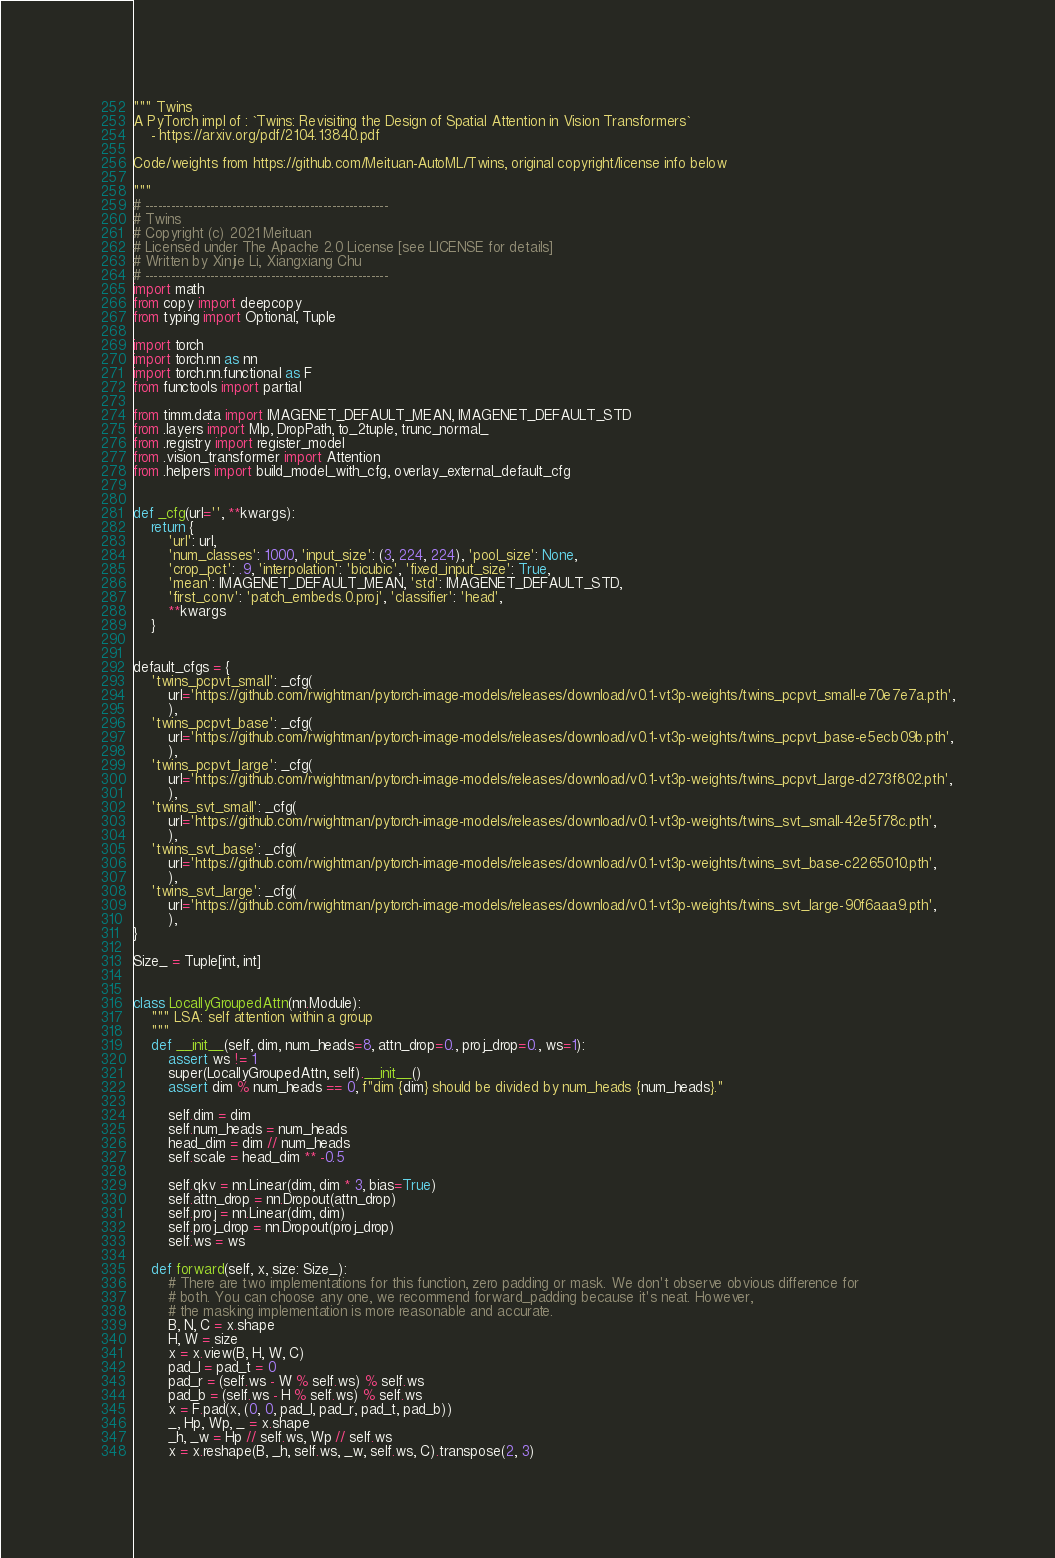Convert code to text. <code><loc_0><loc_0><loc_500><loc_500><_Python_>""" Twins
A PyTorch impl of : `Twins: Revisiting the Design of Spatial Attention in Vision Transformers`
    - https://arxiv.org/pdf/2104.13840.pdf

Code/weights from https://github.com/Meituan-AutoML/Twins, original copyright/license info below

"""
# --------------------------------------------------------
# Twins
# Copyright (c) 2021 Meituan
# Licensed under The Apache 2.0 License [see LICENSE for details]
# Written by Xinjie Li, Xiangxiang Chu
# --------------------------------------------------------
import math
from copy import deepcopy
from typing import Optional, Tuple

import torch
import torch.nn as nn
import torch.nn.functional as F
from functools import partial

from timm.data import IMAGENET_DEFAULT_MEAN, IMAGENET_DEFAULT_STD
from .layers import Mlp, DropPath, to_2tuple, trunc_normal_
from .registry import register_model
from .vision_transformer import Attention
from .helpers import build_model_with_cfg, overlay_external_default_cfg


def _cfg(url='', **kwargs):
    return {
        'url': url,
        'num_classes': 1000, 'input_size': (3, 224, 224), 'pool_size': None,
        'crop_pct': .9, 'interpolation': 'bicubic', 'fixed_input_size': True,
        'mean': IMAGENET_DEFAULT_MEAN, 'std': IMAGENET_DEFAULT_STD,
        'first_conv': 'patch_embeds.0.proj', 'classifier': 'head',
        **kwargs
    }


default_cfgs = {
    'twins_pcpvt_small': _cfg(
        url='https://github.com/rwightman/pytorch-image-models/releases/download/v0.1-vt3p-weights/twins_pcpvt_small-e70e7e7a.pth',
        ),
    'twins_pcpvt_base': _cfg(
        url='https://github.com/rwightman/pytorch-image-models/releases/download/v0.1-vt3p-weights/twins_pcpvt_base-e5ecb09b.pth',
        ),
    'twins_pcpvt_large': _cfg(
        url='https://github.com/rwightman/pytorch-image-models/releases/download/v0.1-vt3p-weights/twins_pcpvt_large-d273f802.pth',
        ),
    'twins_svt_small': _cfg(
        url='https://github.com/rwightman/pytorch-image-models/releases/download/v0.1-vt3p-weights/twins_svt_small-42e5f78c.pth',
        ),
    'twins_svt_base': _cfg(
        url='https://github.com/rwightman/pytorch-image-models/releases/download/v0.1-vt3p-weights/twins_svt_base-c2265010.pth',
        ),
    'twins_svt_large': _cfg(
        url='https://github.com/rwightman/pytorch-image-models/releases/download/v0.1-vt3p-weights/twins_svt_large-90f6aaa9.pth',
        ),
}

Size_ = Tuple[int, int]


class LocallyGroupedAttn(nn.Module):
    """ LSA: self attention within a group
    """
    def __init__(self, dim, num_heads=8, attn_drop=0., proj_drop=0., ws=1):
        assert ws != 1
        super(LocallyGroupedAttn, self).__init__()
        assert dim % num_heads == 0, f"dim {dim} should be divided by num_heads {num_heads}."

        self.dim = dim
        self.num_heads = num_heads
        head_dim = dim // num_heads
        self.scale = head_dim ** -0.5

        self.qkv = nn.Linear(dim, dim * 3, bias=True)
        self.attn_drop = nn.Dropout(attn_drop)
        self.proj = nn.Linear(dim, dim)
        self.proj_drop = nn.Dropout(proj_drop)
        self.ws = ws

    def forward(self, x, size: Size_):
        # There are two implementations for this function, zero padding or mask. We don't observe obvious difference for
        # both. You can choose any one, we recommend forward_padding because it's neat. However,
        # the masking implementation is more reasonable and accurate.
        B, N, C = x.shape
        H, W = size
        x = x.view(B, H, W, C)
        pad_l = pad_t = 0
        pad_r = (self.ws - W % self.ws) % self.ws
        pad_b = (self.ws - H % self.ws) % self.ws
        x = F.pad(x, (0, 0, pad_l, pad_r, pad_t, pad_b))
        _, Hp, Wp, _ = x.shape
        _h, _w = Hp // self.ws, Wp // self.ws
        x = x.reshape(B, _h, self.ws, _w, self.ws, C).transpose(2, 3)</code> 